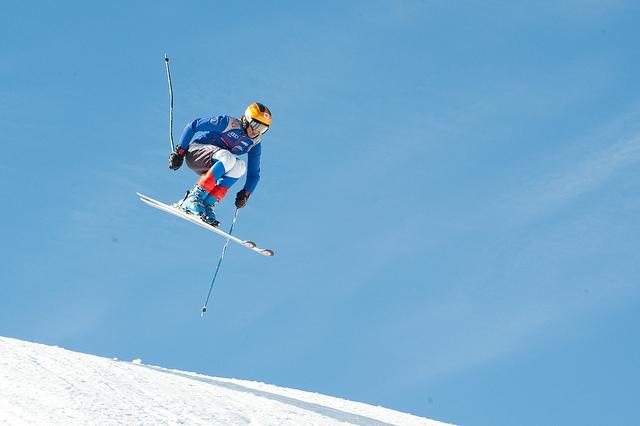What color is this person's outfit?
Give a very brief answer. Blue. What is the print on the man's pants?
Quick response, please. Stripes. Where is the man?
Be succinct. In air. Is the ramp completely covered in snow?
Write a very short answer. Yes. What sport is this?
Quick response, please. Skiing. What is this person riding?
Answer briefly. Skis. Is the sky clear?
Keep it brief. Yes. 